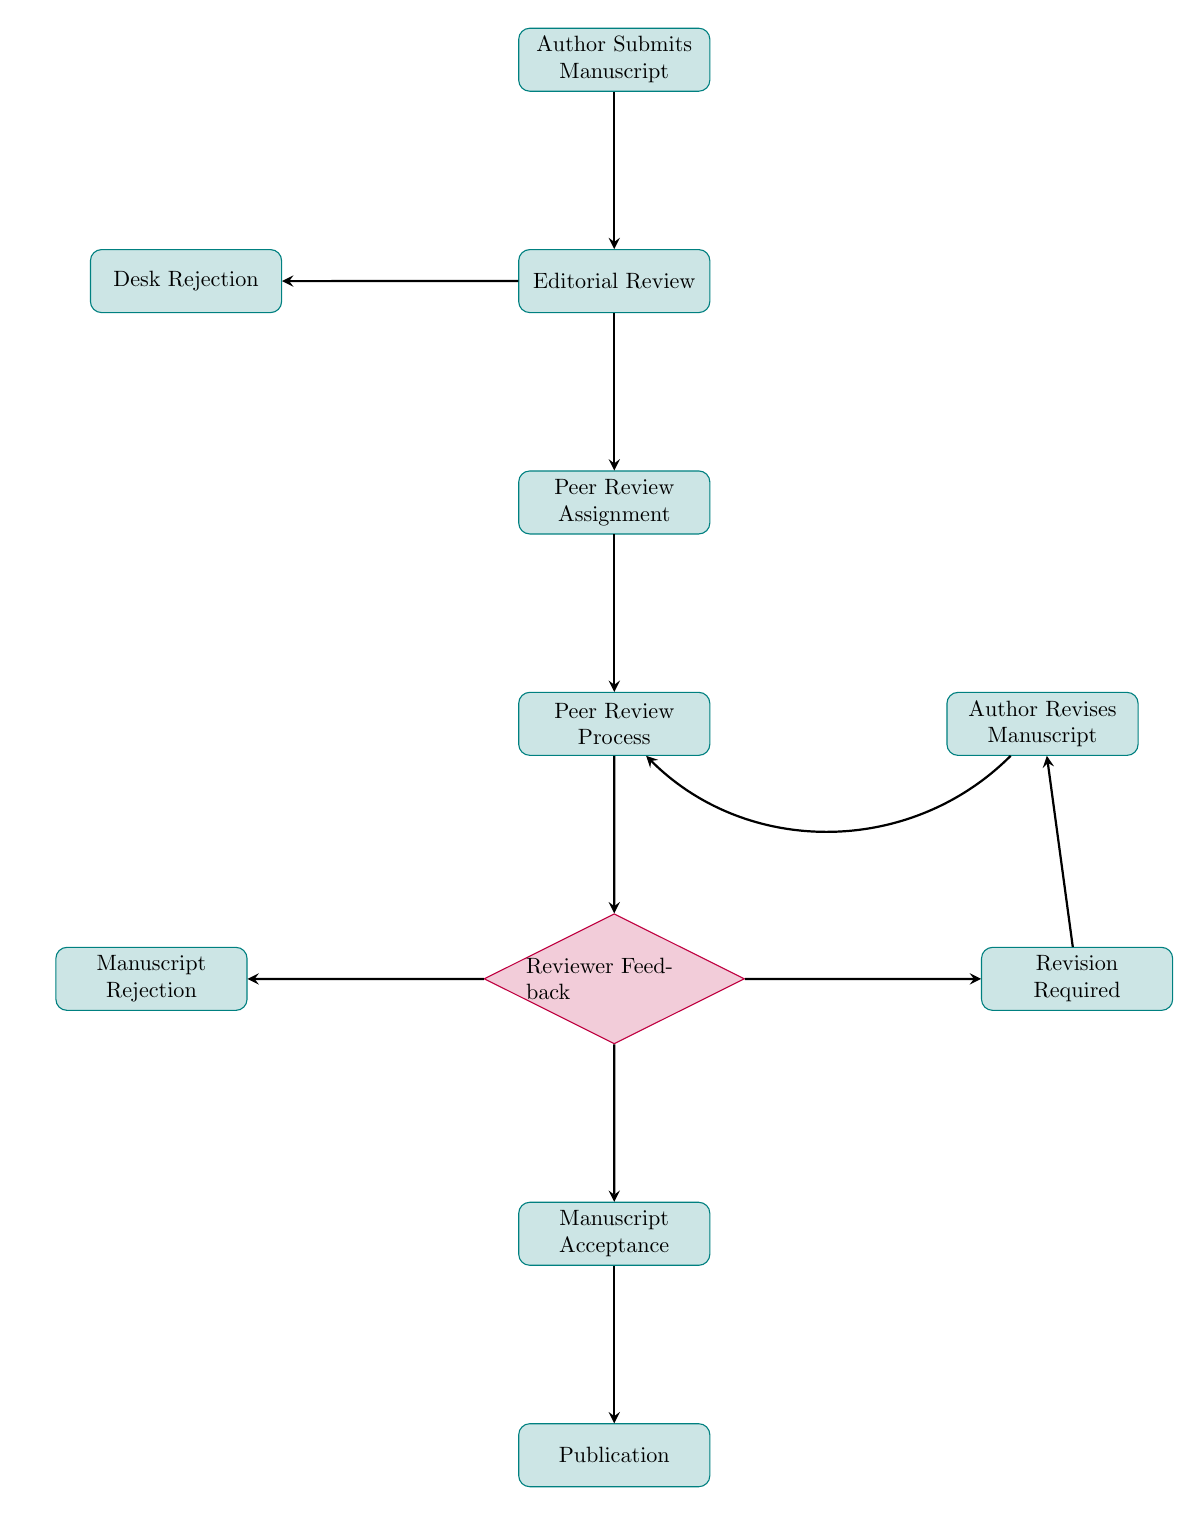What is the first step in the peer review process? The first node in the flow chart identifies the starting point of the process, which is "Author Submits Manuscript."
Answer: Author Submits Manuscript How many pathways diverge from the Editorial Review? The second node, "Editorial Review," has two branches leading out of it: one for "Desk Rejection" and one for "Peer Review Assignment." Therefore, there are two pathways.
Answer: 2 What happens if the manuscript is desk rejected? According to the flow chart, if a manuscript is desk rejected, it does not proceed to any further steps and ends at that node.
Answer: Manuscript Rejected What must the author do if revisions are required? When the "Revision Required" node is reached, the next step indicated is for the "Author Revises Manuscript." This is the action the author must take to address the feedback.
Answer: Author Revises Manuscript What is the endpoint of the peer review process? The final step listed in the flow chart is "Publication," which marks the completion of the peer review process once a manuscript is accepted.
Answer: Publication What type of feedback leads to manuscript acceptance? In the flow chart, "Manuscript Acceptance" is reached only if the feedback from reviewers is predominantly positive, indicating that the manuscript meets the journal's standards.
Answer: Positive Feedback How does the author resubmit the manuscript after revisions? Post-revision, the flow chart indicates that the author resubmits the manuscript, which leads back into the "Peer Review Process" for evaluation again.
Answer: Resubmits Manuscript What is the purpose of the Peer Review Assignment step? The purpose of the "Peer Review Assignment" step is to designate relevant peer reviewers who will evaluate the manuscript, ensuring that their expertise matches the subject matter.
Answer: Assign Peer Reviewers 